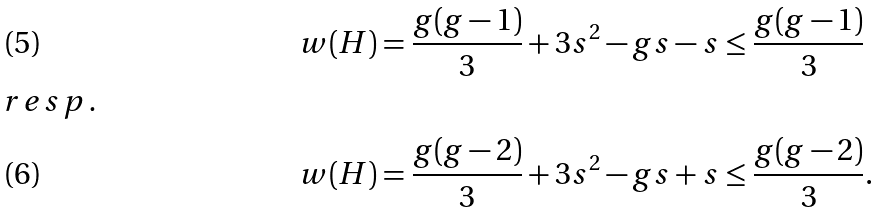Convert formula to latex. <formula><loc_0><loc_0><loc_500><loc_500>w ( H ) & = \frac { g ( g - 1 ) } { 3 } + 3 s ^ { 2 } - g s - s \leq \frac { g ( g - 1 ) } { 3 } \\ \intertext { r e s p . } w ( H ) & = \frac { g ( g - 2 ) } { 3 } + 3 s ^ { 2 } - g s + s \leq \frac { g ( g - 2 ) } { 3 } .</formula> 